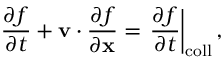<formula> <loc_0><loc_0><loc_500><loc_500>\frac { \partial f } { \partial t } + \mathbf v \cdot \frac { \partial f } { \partial \mathbf x } = \frac { \partial f } { \partial t } \right | _ { c o l l } ,</formula> 